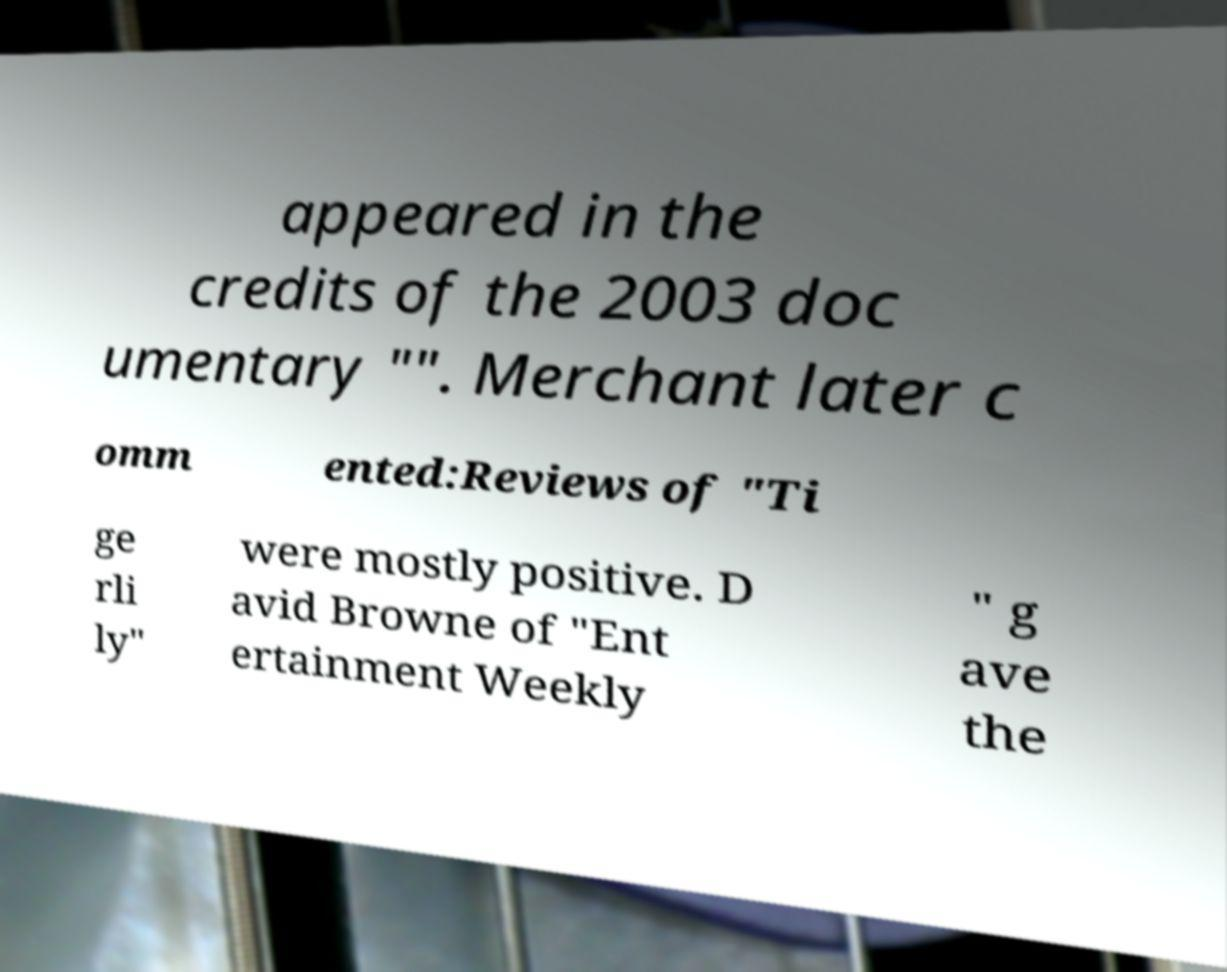For documentation purposes, I need the text within this image transcribed. Could you provide that? appeared in the credits of the 2003 doc umentary "". Merchant later c omm ented:Reviews of "Ti ge rli ly" were mostly positive. D avid Browne of "Ent ertainment Weekly " g ave the 